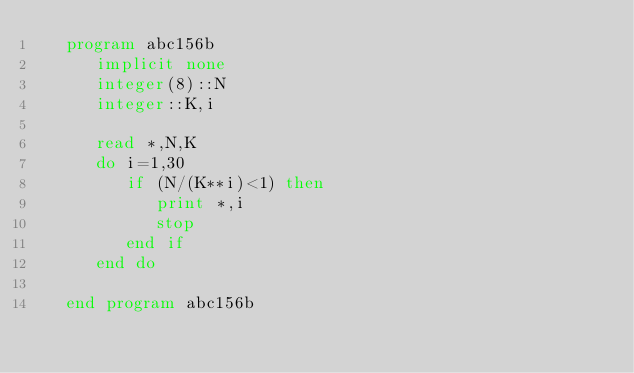Convert code to text. <code><loc_0><loc_0><loc_500><loc_500><_FORTRAN_>   program abc156b
      implicit none
      integer(8)::N
      integer::K,i

      read *,N,K
      do i=1,30
         if (N/(K**i)<1) then
            print *,i
            stop
         end if
      end do

   end program abc156b</code> 